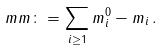<formula> <loc_0><loc_0><loc_500><loc_500>\| \ m m \| \colon = \sum _ { i \geq 1 } m _ { i } ^ { 0 } - m _ { i } \, .</formula> 